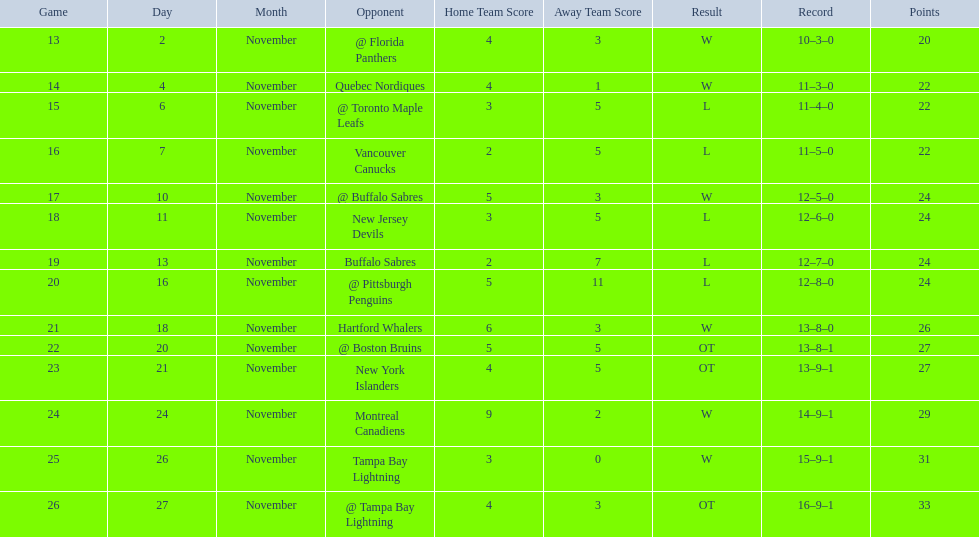Which teams scored 35 points or more in total? Hartford Whalers, @ Boston Bruins, New York Islanders, Montreal Canadiens, Tampa Bay Lightning, @ Tampa Bay Lightning. Of those teams, which team was the only one to score 3-0? Tampa Bay Lightning. 